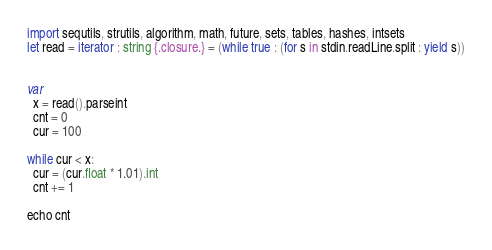Convert code to text. <code><loc_0><loc_0><loc_500><loc_500><_Nim_>import sequtils, strutils, algorithm, math, future, sets, tables, hashes, intsets
let read = iterator : string {.closure.} = (while true : (for s in stdin.readLine.split : yield s))


var
  x = read().parseint
  cnt = 0
  cur = 100

while cur < x:
  cur = (cur.float * 1.01).int
  cnt += 1

echo cnt


</code> 